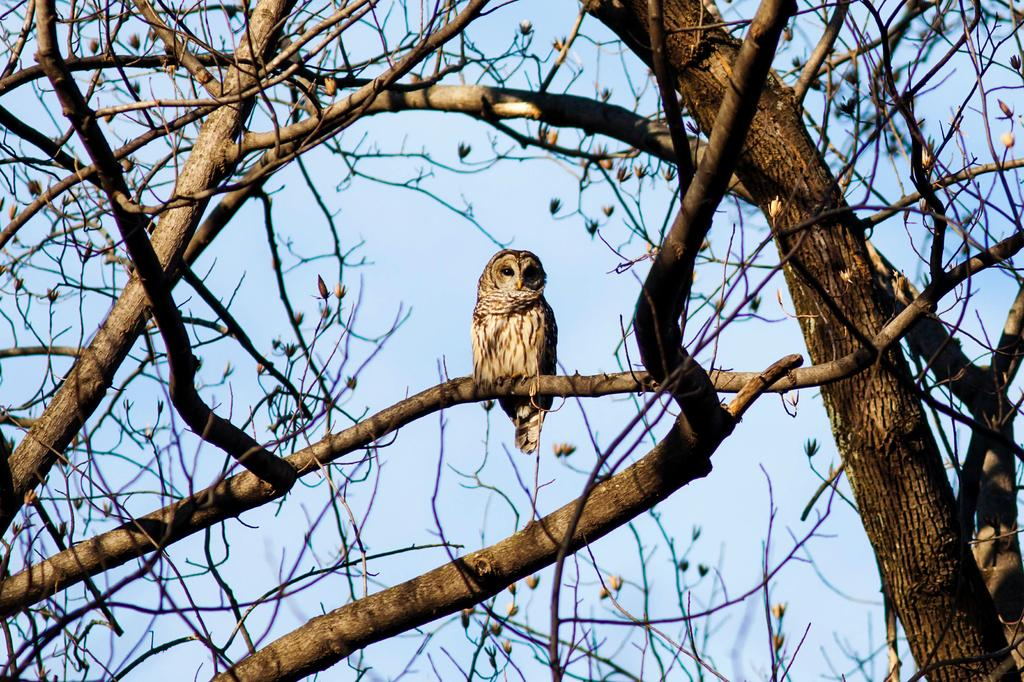What animal is present in the image? There is an owl in the image. Where is the owl located? The owl is on a big tree. What else can be seen on the tree? The tree has flowers. What is visible at the top of the image? The sky is visible at the top of the image. Is there a mailbox near the owl in the image? There is no mailbox present in the image. How many passengers are visible in the image? There are no passengers present in the image; it features an owl on a tree. 